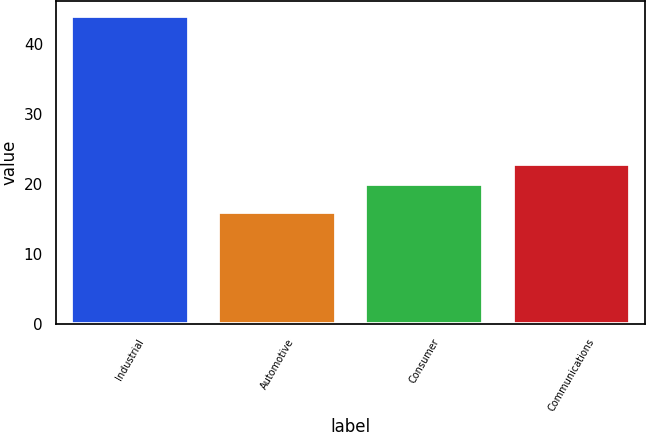<chart> <loc_0><loc_0><loc_500><loc_500><bar_chart><fcel>Industrial<fcel>Automotive<fcel>Consumer<fcel>Communications<nl><fcel>44<fcel>16<fcel>20<fcel>22.8<nl></chart> 